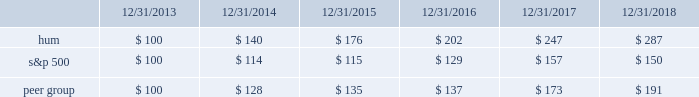Stock total return performance the following graph compares our total return to stockholders with the returns of the standard & poor 2019s composite 500 index ( 201cs&p 500 201d ) and the dow jones us select health care providers index ( 201cpeer group 201d ) for the five years ended december 31 , 2018 .
The graph assumes an investment of $ 100 in each of our common stock , the s&p 500 , and the peer group on december 31 , 2013 , and that dividends were reinvested when paid. .
The stock price performance included in this graph is not necessarily indicative of future stock price performance. .
What was the ratio of the stock total return performance for hum to s&p 500 at 12/31/2016? 
Computations: (202 / 129)
Answer: 1.56589. Stock total return performance the following graph compares our total return to stockholders with the returns of the standard & poor 2019s composite 500 index ( 201cs&p 500 201d ) and the dow jones us select health care providers index ( 201cpeer group 201d ) for the five years ended december 31 , 2018 .
The graph assumes an investment of $ 100 in each of our common stock , the s&p 500 , and the peer group on december 31 , 2013 , and that dividends were reinvested when paid. .
The stock price performance included in this graph is not necessarily indicative of future stock price performance. .
What is the highest return for the first year of the investment? 
Rationale: it is the maximum value for the first year ( 2014 ) , then turned into a percentage to represent the return .
Computations: (140 - 100)
Answer: 40.0. 